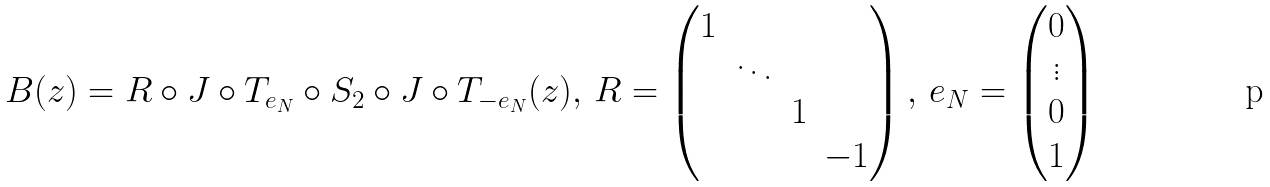<formula> <loc_0><loc_0><loc_500><loc_500>{ B } ( z ) = R \circ J \circ T _ { e _ { N } } \circ S _ { 2 } \circ J \circ T _ { - e _ { N } } ( z ) , \, R = \begin{pmatrix} 1 & & & \\ & \ddots & & \\ & & 1 & \\ & & & - 1 \end{pmatrix} , \, e _ { N } = \begin{pmatrix} 0 \\ \vdots \\ 0 \\ 1 \end{pmatrix}</formula> 